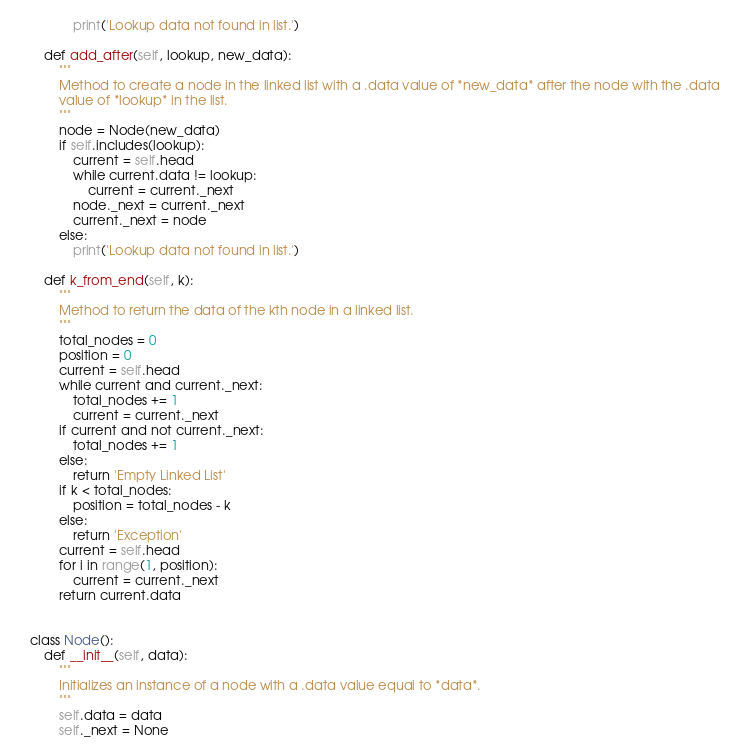<code> <loc_0><loc_0><loc_500><loc_500><_Python_>            print('Lookup data not found in list.')

    def add_after(self, lookup, new_data):
        """
        Method to create a node in the linked list with a .data value of *new_data* after the node with the .data
        value of *lookup* in the list.
        """
        node = Node(new_data)
        if self.includes(lookup):
            current = self.head
            while current.data != lookup:
                current = current._next
            node._next = current._next
            current._next = node
        else:
            print('Lookup data not found in list.')

    def k_from_end(self, k):
        """
        Method to return the data of the kth node in a linked list.
        """
        total_nodes = 0
        position = 0
        current = self.head
        while current and current._next:
            total_nodes += 1
            current = current._next
        if current and not current._next:
            total_nodes += 1
        else:
            return 'Empty Linked List'
        if k < total_nodes:
            position = total_nodes - k
        else:
            return 'Exception'
        current = self.head
        for i in range(1, position):
            current = current._next
        return current.data


class Node():
    def __init__(self, data):
        """
        Initializes an instance of a node with a .data value equal to *data*.
        """
        self.data = data
        self._next = None
</code> 